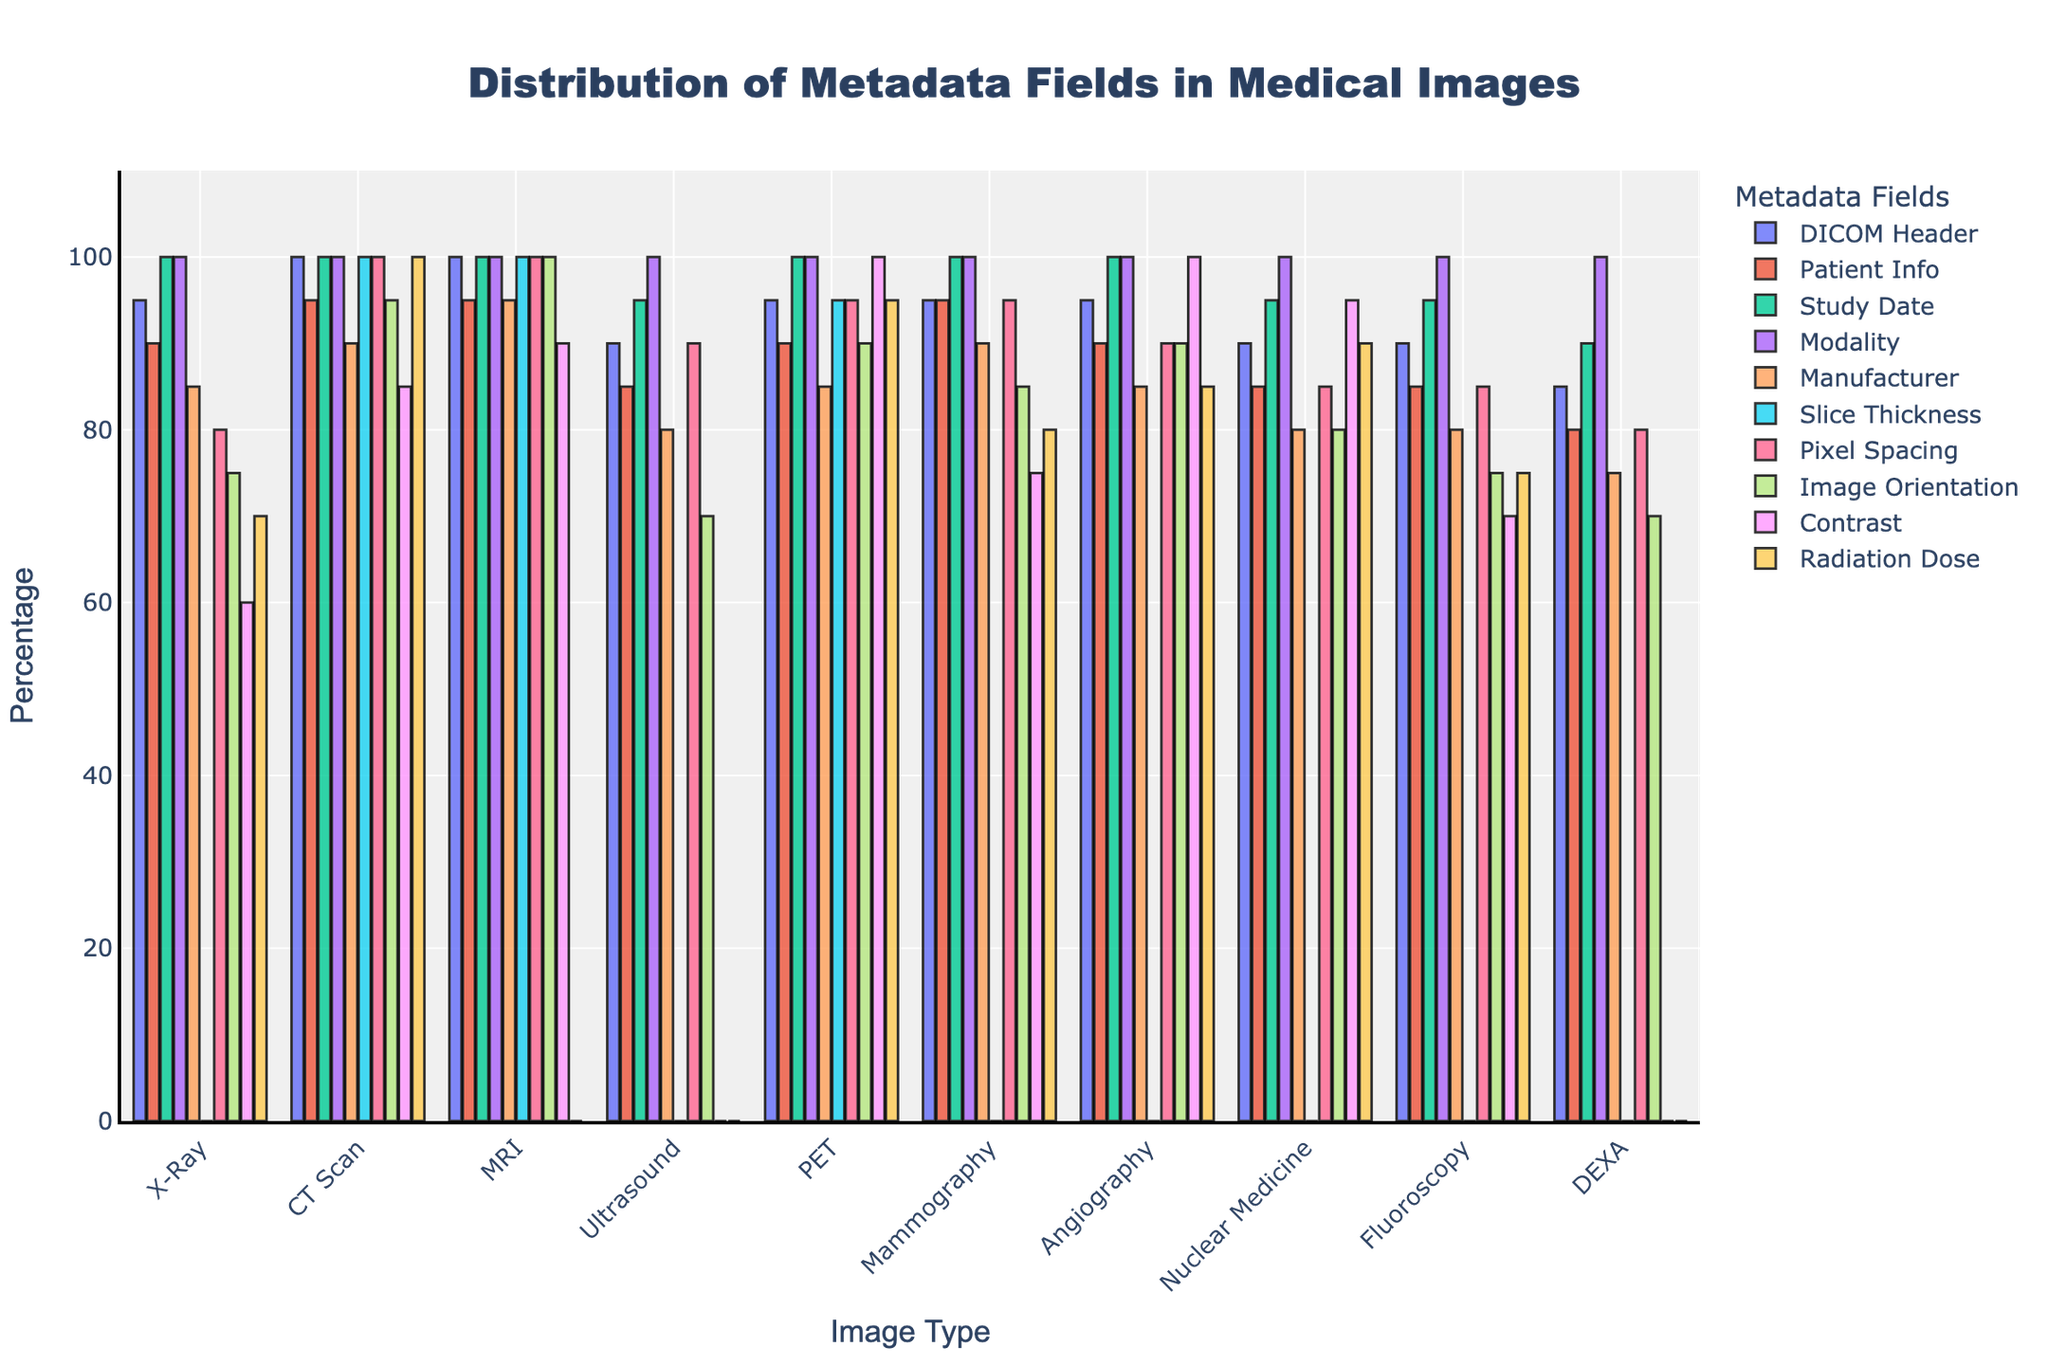What type of medical image has the highest percentage of "Patient Info" field? The "Patient Info" field has the highest percentage for three types of medical images: CT Scan, MRI, and Mammography, all at 95%. This is shown by the bar heights for these image types.
Answer: CT Scan, MRI, Mammography Which medical image type has the lowest percentage of "Radiation Dose" field? The "Radiation Dose" field has a percentage of 0% for three types of medical images: MRI, Ultrasound, and DEXA. This is indicated by the bar heights for these image types.
Answer: MRI, Ultrasound, DEXA What is the sum of the "Slice Thickness" percentage across all image types? Adding up the "Slice Thickness" percentages from the figure: X-Ray (0) + CT Scan (100) + MRI (100) + Ultrasound (0) + PET (95) + Mammography (0) + Angiography (0) + Nuclear Medicine (0) + Fluoroscopy (0) + DEXA (0) = 295.
Answer: 295 Which medical image type has the closest percentages in "Pixel Spacing" and "DICOM Header" fields? The X-Ray image type has "Pixel Spacing" at 80% and "DICOM Header" at 95%, which are the closest percentages among all types when comparing these two fields.
Answer: X-Ray How does the percentage of the "Manufacturer" field vary between X-Ray and MRI? The percentage for the "Manufacturer" field is higher in MRI (95%) than in X-Ray (85%). This is seen by comparing the bar heights for this field in the two image types.
Answer: MRI > X-Ray (95% vs 85%) What is the average percentage of the "Modality" field across all image types? The percentages for the "Modality" field are as follows: X-Ray (100), CT Scan (100), MRI (100), Ultrasound (100), PET (100), Mammography (100), Angiography (100), Nuclear Medicine (100), Fluoroscopy (100), and DEXA (100). Sum these up and divide by the number of types (10): (100*10)/10 = 100.
Answer: 100% Which image type has the largest difference between the "Study Date" and "Radiation Dose" fields? MRI has 100% for "Study Date" and 0% for "Radiation Dose". The difference is 100% - 0% = 100%, the largest among all types.
Answer: MRI Which metadata field has the highest percentage in "Ultrasound" image type? The "Modality" field has the highest percentage in the Ultrasound image type at 100%. This is shown by the tallest bar in the Ultrasound category.
Answer: Modality What is the median percentage of the "Patient Info" field across all medical image types? The percentages for the "Patient Info" field are: 90, 95, 95, 85, 90, 95, 90, 85, 85, 80. Ordering them: 80, 85, 85, 85, 90, 90, 90, 95, 95, 95. The median, being the middle value between the 5th and 6th terms, is (90+90)/2 = 90.
Answer: 90 